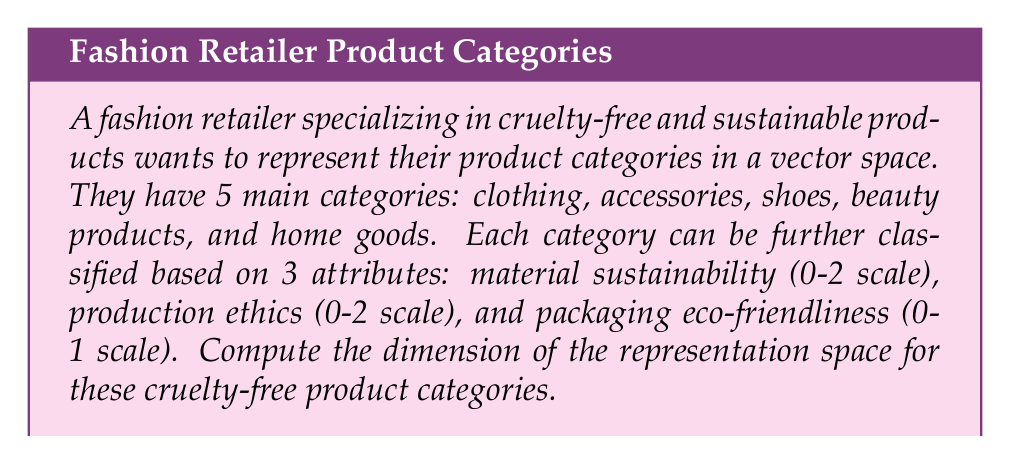Can you solve this math problem? To determine the dimension of the representation space, we need to follow these steps:

1) First, identify the number of independent variables:
   - 5 main categories
   - 3 attributes for each category

2) For each category, we need to represent:
   - Material sustainability: 3 possible values (0, 1, 2)
   - Production ethics: 3 possible values (0, 1, 2)
   - Packaging eco-friendliness: 2 possible values (0, 1)

3) For each category, we can represent these attributes as a vector:
   $$(s, e, p)$$
   where $s$ is sustainability, $e$ is ethics, and $p$ is packaging.

4) The number of possible combinations for each category is:
   $$3 \times 3 \times 2 = 18$$

5) Since we have 5 categories, and each category can be represented by an 18-dimensional vector, the total dimension of the representation space is:

   $$5 \times 18 = 90$$

Therefore, the dimension of the representation space for the cruelty-free product categories is 90.
Answer: 90 